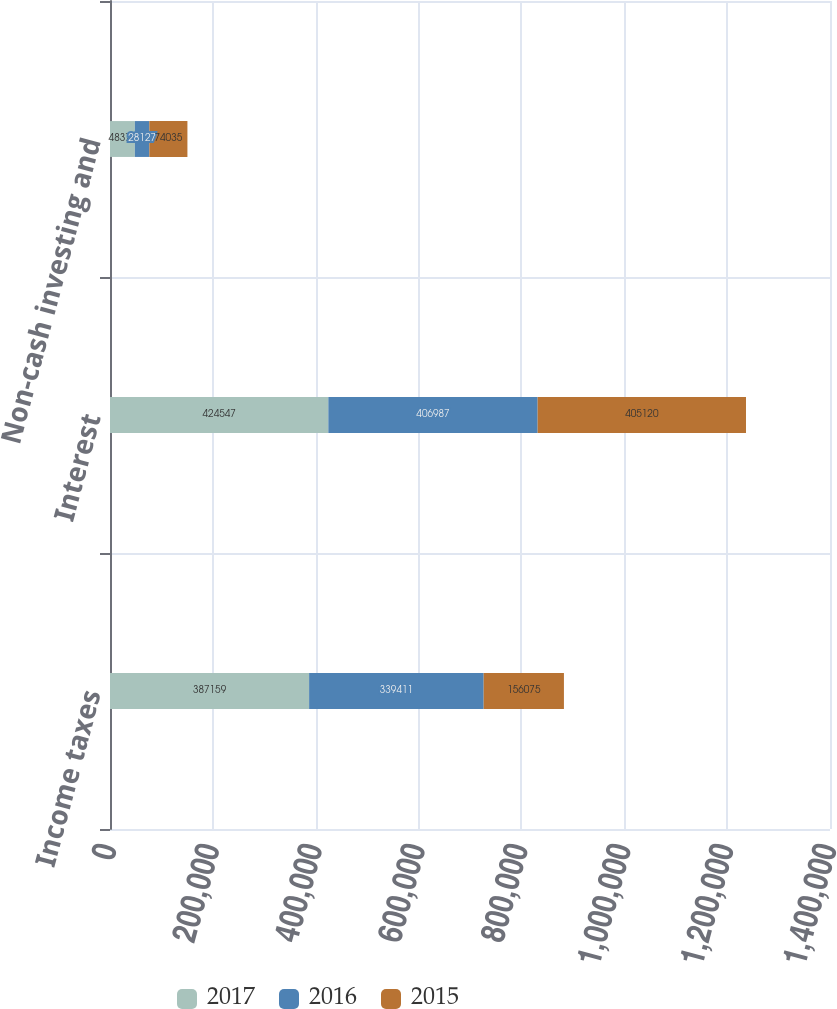Convert chart. <chart><loc_0><loc_0><loc_500><loc_500><stacked_bar_chart><ecel><fcel>Income taxes<fcel>Interest<fcel>Non-cash investing and<nl><fcel>2017<fcel>387159<fcel>424547<fcel>48378<nl><fcel>2016<fcel>339411<fcel>406987<fcel>28127<nl><fcel>2015<fcel>156075<fcel>405120<fcel>74035<nl></chart> 